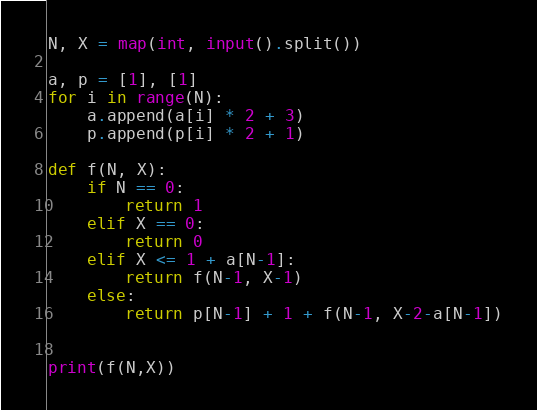<code> <loc_0><loc_0><loc_500><loc_500><_Python_>N, X = map(int, input().split())

a, p = [1], [1]
for i in range(N):
    a.append(a[i] * 2 + 3)
    p.append(p[i] * 2 + 1)

def f(N, X):
    if N == 0:
        return 1
    elif X == 0:
        return 0
    elif X <= 1 + a[N-1]:
        return f(N-1, X-1)
    else:
        return p[N-1] + 1 + f(N-1, X-2-a[N-1])


print(f(N,X))</code> 